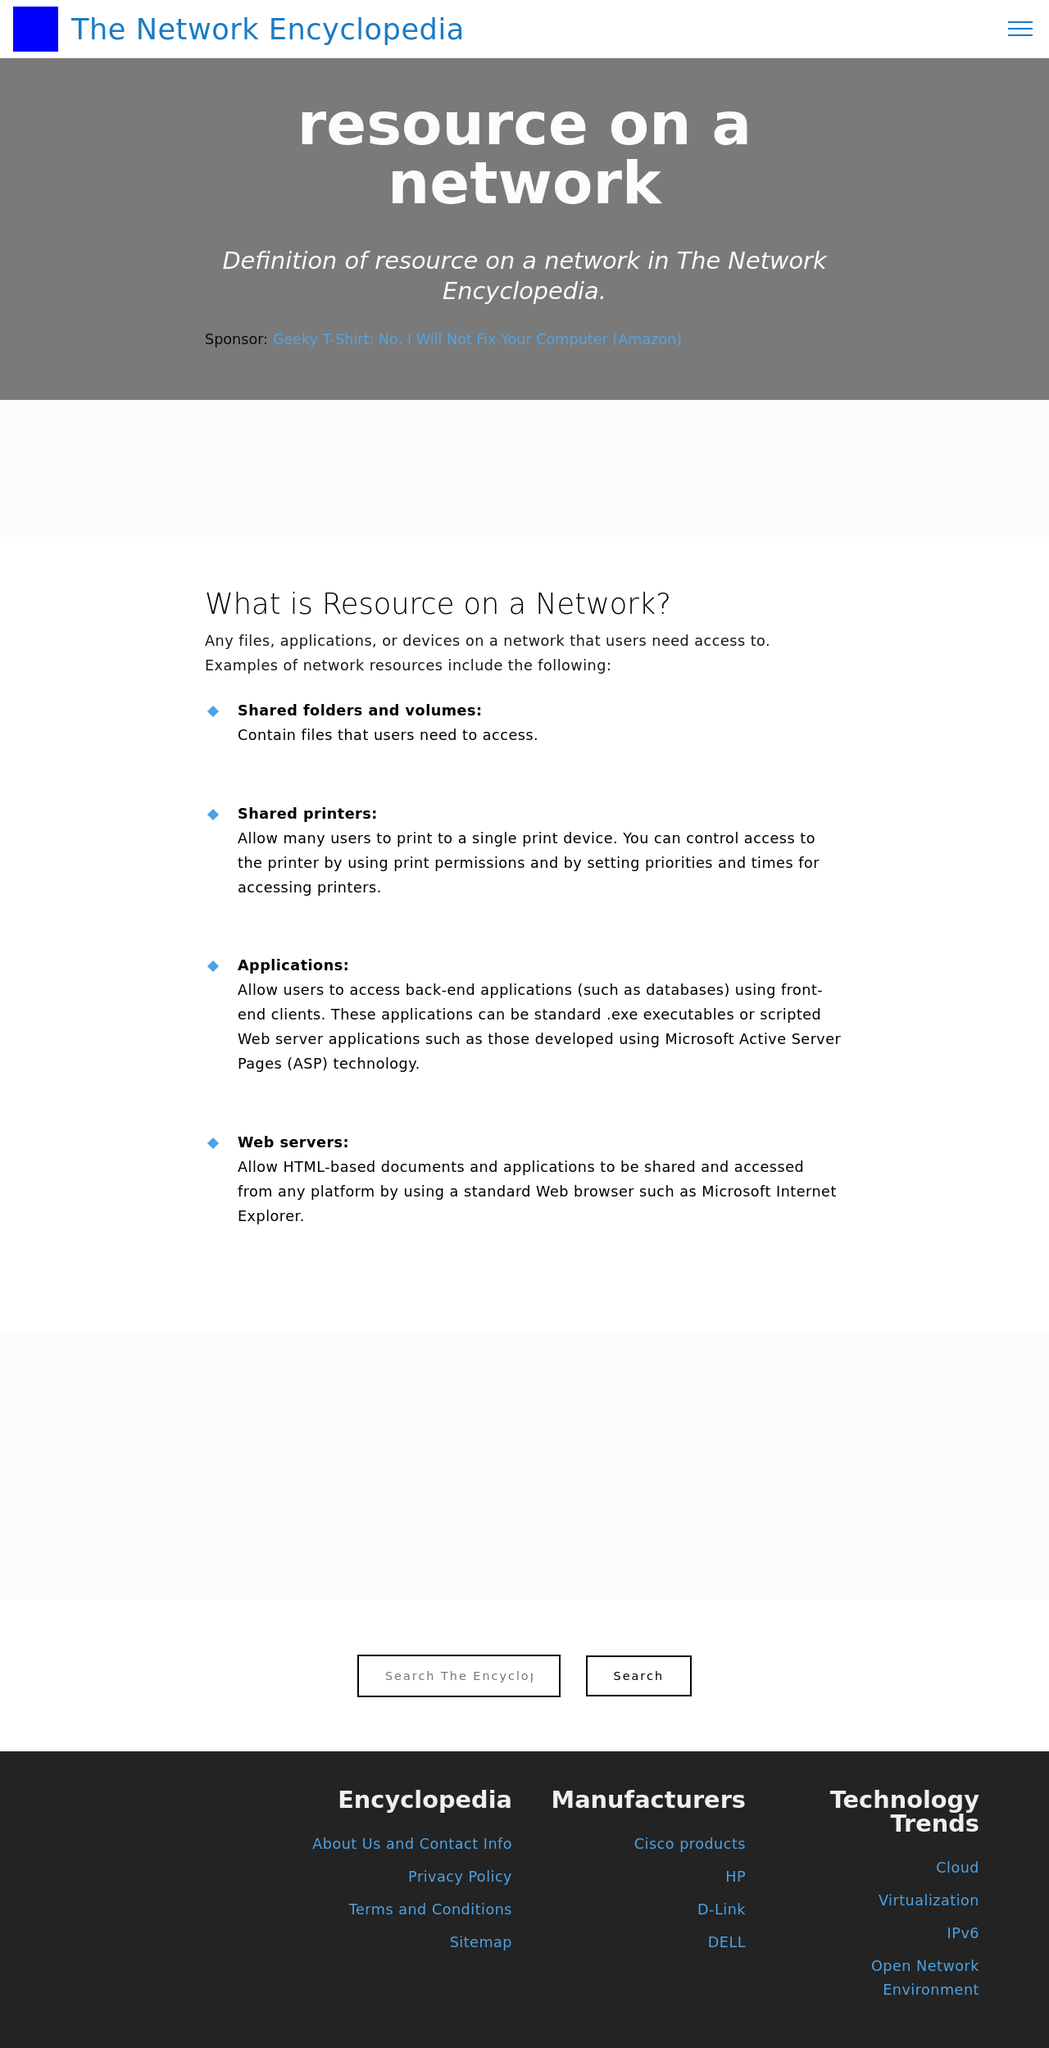Could you suggest some improvements for the design of this website based on the image? Based on the image, the website could benefit from the following design improvements:
1. **Enhanced Navigation**: The menu could be made more prominent with clearer, larger typefaces or additional hover effects to improve usability.
2. **Visual Appeal**: Introducing more color contrast and graphical elements could make the site more visually engaging.
3. **Content Organization**: Streamlining the content layout to minimize scrolling and more effectively categorize sections can enhance readability and user experience.
4. **Interactive Features**: Adding interactive elements like videos or animated infographics could make the learning experience more engaging for users.
5. **Responsive Design**: Ensuring that the site is fully responsive to provide a smooth experience across all devices would be crucial. 